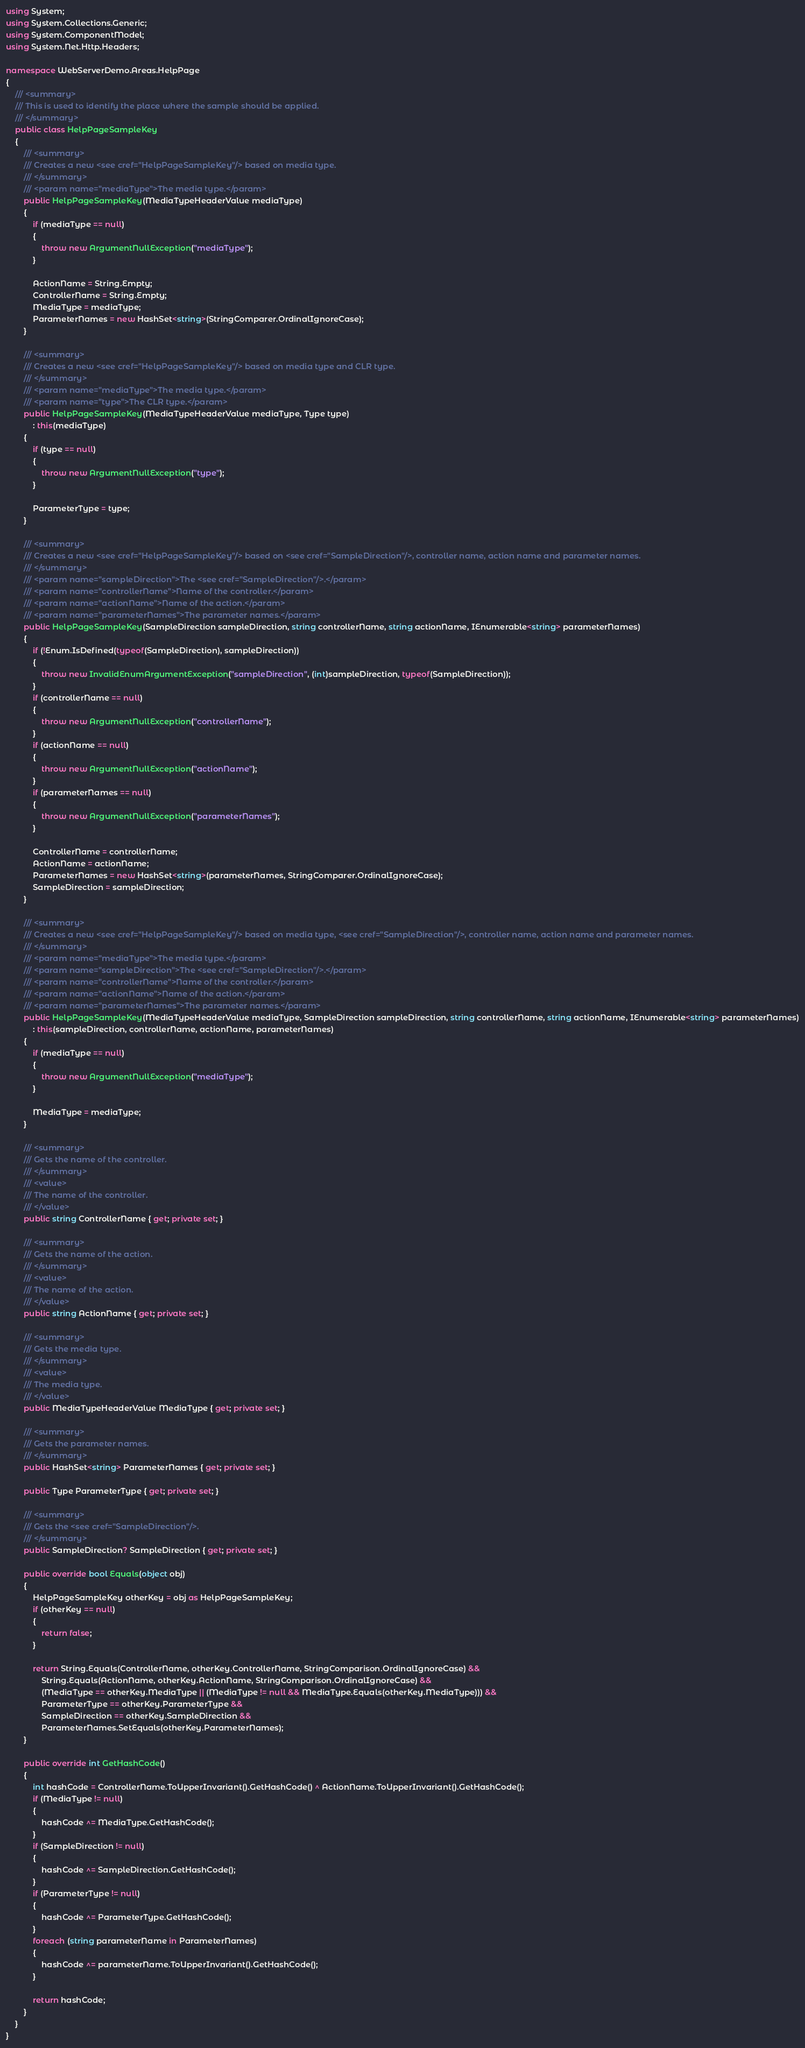Convert code to text. <code><loc_0><loc_0><loc_500><loc_500><_C#_>using System;
using System.Collections.Generic;
using System.ComponentModel;
using System.Net.Http.Headers;

namespace WebServerDemo.Areas.HelpPage
{
    /// <summary>
    /// This is used to identify the place where the sample should be applied.
    /// </summary>
    public class HelpPageSampleKey
    {
        /// <summary>
        /// Creates a new <see cref="HelpPageSampleKey"/> based on media type.
        /// </summary>
        /// <param name="mediaType">The media type.</param>
        public HelpPageSampleKey(MediaTypeHeaderValue mediaType)
        {
            if (mediaType == null)
            {
                throw new ArgumentNullException("mediaType");
            }

            ActionName = String.Empty;
            ControllerName = String.Empty;
            MediaType = mediaType;
            ParameterNames = new HashSet<string>(StringComparer.OrdinalIgnoreCase);
        }

        /// <summary>
        /// Creates a new <see cref="HelpPageSampleKey"/> based on media type and CLR type.
        /// </summary>
        /// <param name="mediaType">The media type.</param>
        /// <param name="type">The CLR type.</param>
        public HelpPageSampleKey(MediaTypeHeaderValue mediaType, Type type)
            : this(mediaType)
        {
            if (type == null)
            {
                throw new ArgumentNullException("type");
            }

            ParameterType = type;
        }

        /// <summary>
        /// Creates a new <see cref="HelpPageSampleKey"/> based on <see cref="SampleDirection"/>, controller name, action name and parameter names.
        /// </summary>
        /// <param name="sampleDirection">The <see cref="SampleDirection"/>.</param>
        /// <param name="controllerName">Name of the controller.</param>
        /// <param name="actionName">Name of the action.</param>
        /// <param name="parameterNames">The parameter names.</param>
        public HelpPageSampleKey(SampleDirection sampleDirection, string controllerName, string actionName, IEnumerable<string> parameterNames)
        {
            if (!Enum.IsDefined(typeof(SampleDirection), sampleDirection))
            {
                throw new InvalidEnumArgumentException("sampleDirection", (int)sampleDirection, typeof(SampleDirection));
            }
            if (controllerName == null)
            {
                throw new ArgumentNullException("controllerName");
            }
            if (actionName == null)
            {
                throw new ArgumentNullException("actionName");
            }
            if (parameterNames == null)
            {
                throw new ArgumentNullException("parameterNames");
            }

            ControllerName = controllerName;
            ActionName = actionName;
            ParameterNames = new HashSet<string>(parameterNames, StringComparer.OrdinalIgnoreCase);
            SampleDirection = sampleDirection;
        }

        /// <summary>
        /// Creates a new <see cref="HelpPageSampleKey"/> based on media type, <see cref="SampleDirection"/>, controller name, action name and parameter names.
        /// </summary>
        /// <param name="mediaType">The media type.</param>
        /// <param name="sampleDirection">The <see cref="SampleDirection"/>.</param>
        /// <param name="controllerName">Name of the controller.</param>
        /// <param name="actionName">Name of the action.</param>
        /// <param name="parameterNames">The parameter names.</param>
        public HelpPageSampleKey(MediaTypeHeaderValue mediaType, SampleDirection sampleDirection, string controllerName, string actionName, IEnumerable<string> parameterNames)
            : this(sampleDirection, controllerName, actionName, parameterNames)
        {
            if (mediaType == null)
            {
                throw new ArgumentNullException("mediaType");
            }

            MediaType = mediaType;
        }

        /// <summary>
        /// Gets the name of the controller.
        /// </summary>
        /// <value>
        /// The name of the controller.
        /// </value>
        public string ControllerName { get; private set; }

        /// <summary>
        /// Gets the name of the action.
        /// </summary>
        /// <value>
        /// The name of the action.
        /// </value>
        public string ActionName { get; private set; }

        /// <summary>
        /// Gets the media type.
        /// </summary>
        /// <value>
        /// The media type.
        /// </value>
        public MediaTypeHeaderValue MediaType { get; private set; }

        /// <summary>
        /// Gets the parameter names.
        /// </summary>
        public HashSet<string> ParameterNames { get; private set; }

        public Type ParameterType { get; private set; }

        /// <summary>
        /// Gets the <see cref="SampleDirection"/>.
        /// </summary>
        public SampleDirection? SampleDirection { get; private set; }

        public override bool Equals(object obj)
        {
            HelpPageSampleKey otherKey = obj as HelpPageSampleKey;
            if (otherKey == null)
            {
                return false;
            }

            return String.Equals(ControllerName, otherKey.ControllerName, StringComparison.OrdinalIgnoreCase) &&
                String.Equals(ActionName, otherKey.ActionName, StringComparison.OrdinalIgnoreCase) &&
                (MediaType == otherKey.MediaType || (MediaType != null && MediaType.Equals(otherKey.MediaType))) &&
                ParameterType == otherKey.ParameterType &&
                SampleDirection == otherKey.SampleDirection &&
                ParameterNames.SetEquals(otherKey.ParameterNames);
        }

        public override int GetHashCode()
        {
            int hashCode = ControllerName.ToUpperInvariant().GetHashCode() ^ ActionName.ToUpperInvariant().GetHashCode();
            if (MediaType != null)
            {
                hashCode ^= MediaType.GetHashCode();
            }
            if (SampleDirection != null)
            {
                hashCode ^= SampleDirection.GetHashCode();
            }
            if (ParameterType != null)
            {
                hashCode ^= ParameterType.GetHashCode();
            }
            foreach (string parameterName in ParameterNames)
            {
                hashCode ^= parameterName.ToUpperInvariant().GetHashCode();
            }

            return hashCode;
        }
    }
}
</code> 